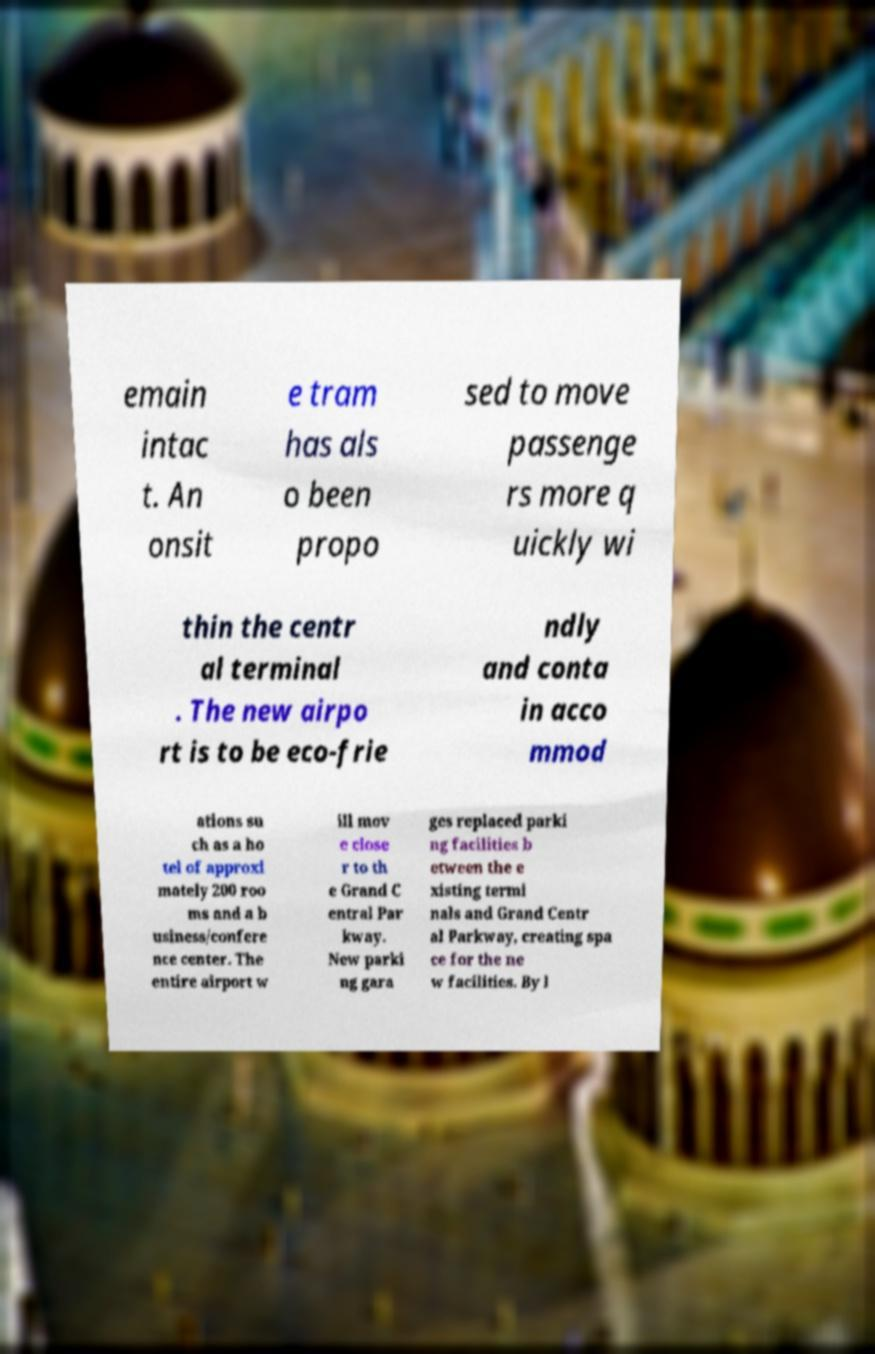Could you assist in decoding the text presented in this image and type it out clearly? emain intac t. An onsit e tram has als o been propo sed to move passenge rs more q uickly wi thin the centr al terminal . The new airpo rt is to be eco-frie ndly and conta in acco mmod ations su ch as a ho tel of approxi mately 200 roo ms and a b usiness/confere nce center. The entire airport w ill mov e close r to th e Grand C entral Par kway. New parki ng gara ges replaced parki ng facilities b etween the e xisting termi nals and Grand Centr al Parkway, creating spa ce for the ne w facilities. By l 